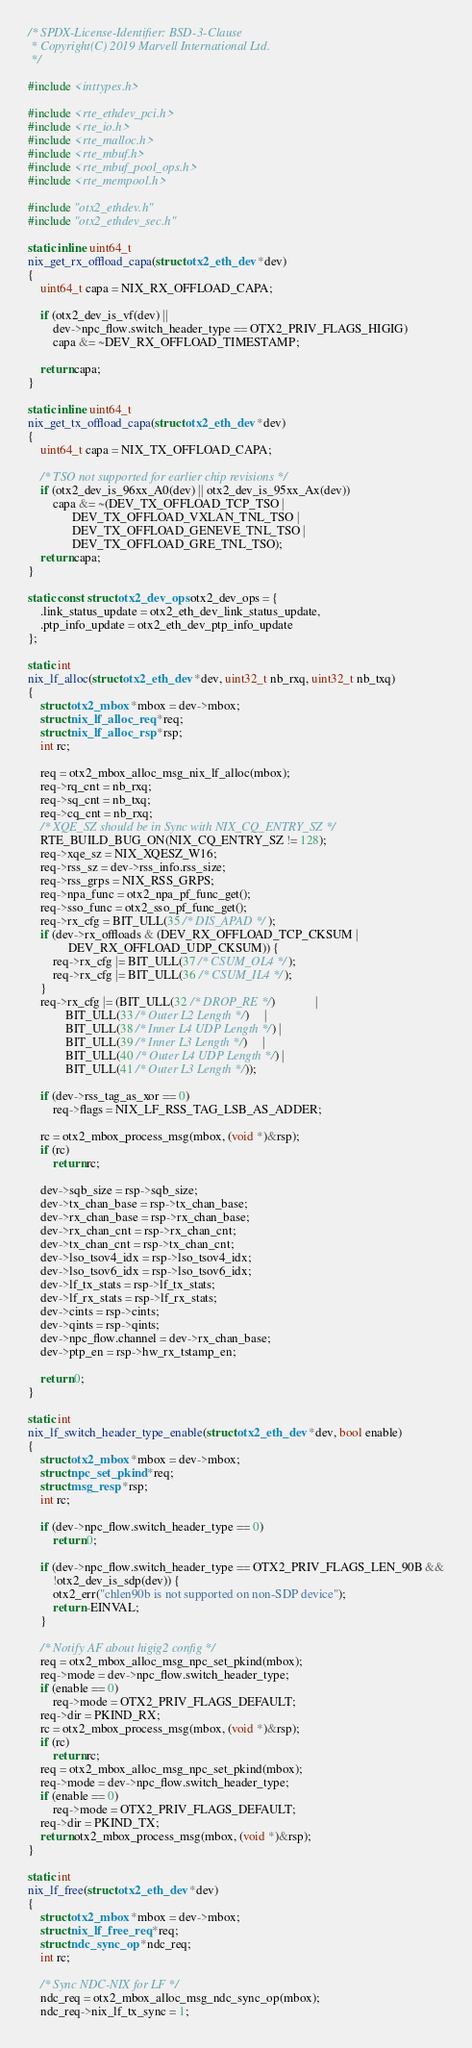Convert code to text. <code><loc_0><loc_0><loc_500><loc_500><_C_>/* SPDX-License-Identifier: BSD-3-Clause
 * Copyright(C) 2019 Marvell International Ltd.
 */

#include <inttypes.h>

#include <rte_ethdev_pci.h>
#include <rte_io.h>
#include <rte_malloc.h>
#include <rte_mbuf.h>
#include <rte_mbuf_pool_ops.h>
#include <rte_mempool.h>

#include "otx2_ethdev.h"
#include "otx2_ethdev_sec.h"

static inline uint64_t
nix_get_rx_offload_capa(struct otx2_eth_dev *dev)
{
	uint64_t capa = NIX_RX_OFFLOAD_CAPA;

	if (otx2_dev_is_vf(dev) ||
	    dev->npc_flow.switch_header_type == OTX2_PRIV_FLAGS_HIGIG)
		capa &= ~DEV_RX_OFFLOAD_TIMESTAMP;

	return capa;
}

static inline uint64_t
nix_get_tx_offload_capa(struct otx2_eth_dev *dev)
{
	uint64_t capa = NIX_TX_OFFLOAD_CAPA;

	/* TSO not supported for earlier chip revisions */
	if (otx2_dev_is_96xx_A0(dev) || otx2_dev_is_95xx_Ax(dev))
		capa &= ~(DEV_TX_OFFLOAD_TCP_TSO |
			  DEV_TX_OFFLOAD_VXLAN_TNL_TSO |
			  DEV_TX_OFFLOAD_GENEVE_TNL_TSO |
			  DEV_TX_OFFLOAD_GRE_TNL_TSO);
	return capa;
}

static const struct otx2_dev_ops otx2_dev_ops = {
	.link_status_update = otx2_eth_dev_link_status_update,
	.ptp_info_update = otx2_eth_dev_ptp_info_update
};

static int
nix_lf_alloc(struct otx2_eth_dev *dev, uint32_t nb_rxq, uint32_t nb_txq)
{
	struct otx2_mbox *mbox = dev->mbox;
	struct nix_lf_alloc_req *req;
	struct nix_lf_alloc_rsp *rsp;
	int rc;

	req = otx2_mbox_alloc_msg_nix_lf_alloc(mbox);
	req->rq_cnt = nb_rxq;
	req->sq_cnt = nb_txq;
	req->cq_cnt = nb_rxq;
	/* XQE_SZ should be in Sync with NIX_CQ_ENTRY_SZ */
	RTE_BUILD_BUG_ON(NIX_CQ_ENTRY_SZ != 128);
	req->xqe_sz = NIX_XQESZ_W16;
	req->rss_sz = dev->rss_info.rss_size;
	req->rss_grps = NIX_RSS_GRPS;
	req->npa_func = otx2_npa_pf_func_get();
	req->sso_func = otx2_sso_pf_func_get();
	req->rx_cfg = BIT_ULL(35 /* DIS_APAD */);
	if (dev->rx_offloads & (DEV_RX_OFFLOAD_TCP_CKSUM |
			 DEV_RX_OFFLOAD_UDP_CKSUM)) {
		req->rx_cfg |= BIT_ULL(37 /* CSUM_OL4 */);
		req->rx_cfg |= BIT_ULL(36 /* CSUM_IL4 */);
	}
	req->rx_cfg |= (BIT_ULL(32 /* DROP_RE */)             |
			BIT_ULL(33 /* Outer L2 Length */)     |
			BIT_ULL(38 /* Inner L4 UDP Length */) |
			BIT_ULL(39 /* Inner L3 Length */)     |
			BIT_ULL(40 /* Outer L4 UDP Length */) |
			BIT_ULL(41 /* Outer L3 Length */));

	if (dev->rss_tag_as_xor == 0)
		req->flags = NIX_LF_RSS_TAG_LSB_AS_ADDER;

	rc = otx2_mbox_process_msg(mbox, (void *)&rsp);
	if (rc)
		return rc;

	dev->sqb_size = rsp->sqb_size;
	dev->tx_chan_base = rsp->tx_chan_base;
	dev->rx_chan_base = rsp->rx_chan_base;
	dev->rx_chan_cnt = rsp->rx_chan_cnt;
	dev->tx_chan_cnt = rsp->tx_chan_cnt;
	dev->lso_tsov4_idx = rsp->lso_tsov4_idx;
	dev->lso_tsov6_idx = rsp->lso_tsov6_idx;
	dev->lf_tx_stats = rsp->lf_tx_stats;
	dev->lf_rx_stats = rsp->lf_rx_stats;
	dev->cints = rsp->cints;
	dev->qints = rsp->qints;
	dev->npc_flow.channel = dev->rx_chan_base;
	dev->ptp_en = rsp->hw_rx_tstamp_en;

	return 0;
}

static int
nix_lf_switch_header_type_enable(struct otx2_eth_dev *dev, bool enable)
{
	struct otx2_mbox *mbox = dev->mbox;
	struct npc_set_pkind *req;
	struct msg_resp *rsp;
	int rc;

	if (dev->npc_flow.switch_header_type == 0)
		return 0;

	if (dev->npc_flow.switch_header_type == OTX2_PRIV_FLAGS_LEN_90B &&
	    !otx2_dev_is_sdp(dev)) {
		otx2_err("chlen90b is not supported on non-SDP device");
		return -EINVAL;
	}

	/* Notify AF about higig2 config */
	req = otx2_mbox_alloc_msg_npc_set_pkind(mbox);
	req->mode = dev->npc_flow.switch_header_type;
	if (enable == 0)
		req->mode = OTX2_PRIV_FLAGS_DEFAULT;
	req->dir = PKIND_RX;
	rc = otx2_mbox_process_msg(mbox, (void *)&rsp);
	if (rc)
		return rc;
	req = otx2_mbox_alloc_msg_npc_set_pkind(mbox);
	req->mode = dev->npc_flow.switch_header_type;
	if (enable == 0)
		req->mode = OTX2_PRIV_FLAGS_DEFAULT;
	req->dir = PKIND_TX;
	return otx2_mbox_process_msg(mbox, (void *)&rsp);
}

static int
nix_lf_free(struct otx2_eth_dev *dev)
{
	struct otx2_mbox *mbox = dev->mbox;
	struct nix_lf_free_req *req;
	struct ndc_sync_op *ndc_req;
	int rc;

	/* Sync NDC-NIX for LF */
	ndc_req = otx2_mbox_alloc_msg_ndc_sync_op(mbox);
	ndc_req->nix_lf_tx_sync = 1;</code> 